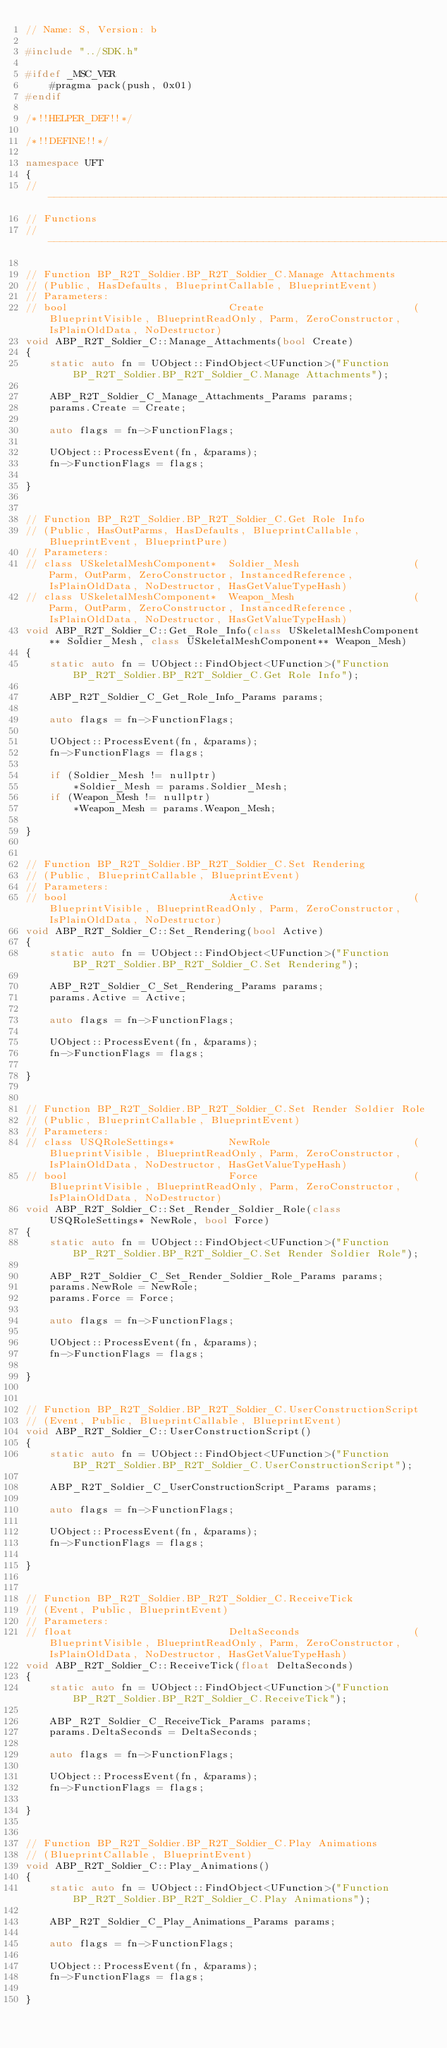Convert code to text. <code><loc_0><loc_0><loc_500><loc_500><_C++_>// Name: S, Version: b

#include "../SDK.h"

#ifdef _MSC_VER
	#pragma pack(push, 0x01)
#endif

/*!!HELPER_DEF!!*/

/*!!DEFINE!!*/

namespace UFT
{
//---------------------------------------------------------------------------
// Functions
//---------------------------------------------------------------------------

// Function BP_R2T_Soldier.BP_R2T_Soldier_C.Manage Attachments
// (Public, HasDefaults, BlueprintCallable, BlueprintEvent)
// Parameters:
// bool                           Create                         (BlueprintVisible, BlueprintReadOnly, Parm, ZeroConstructor, IsPlainOldData, NoDestructor)
void ABP_R2T_Soldier_C::Manage_Attachments(bool Create)
{
	static auto fn = UObject::FindObject<UFunction>("Function BP_R2T_Soldier.BP_R2T_Soldier_C.Manage Attachments");

	ABP_R2T_Soldier_C_Manage_Attachments_Params params;
	params.Create = Create;

	auto flags = fn->FunctionFlags;

	UObject::ProcessEvent(fn, &params);
	fn->FunctionFlags = flags;

}


// Function BP_R2T_Soldier.BP_R2T_Soldier_C.Get Role Info
// (Public, HasOutParms, HasDefaults, BlueprintCallable, BlueprintEvent, BlueprintPure)
// Parameters:
// class USkeletalMeshComponent*  Soldier_Mesh                   (Parm, OutParm, ZeroConstructor, InstancedReference, IsPlainOldData, NoDestructor, HasGetValueTypeHash)
// class USkeletalMeshComponent*  Weapon_Mesh                    (Parm, OutParm, ZeroConstructor, InstancedReference, IsPlainOldData, NoDestructor, HasGetValueTypeHash)
void ABP_R2T_Soldier_C::Get_Role_Info(class USkeletalMeshComponent** Soldier_Mesh, class USkeletalMeshComponent** Weapon_Mesh)
{
	static auto fn = UObject::FindObject<UFunction>("Function BP_R2T_Soldier.BP_R2T_Soldier_C.Get Role Info");

	ABP_R2T_Soldier_C_Get_Role_Info_Params params;

	auto flags = fn->FunctionFlags;

	UObject::ProcessEvent(fn, &params);
	fn->FunctionFlags = flags;

	if (Soldier_Mesh != nullptr)
		*Soldier_Mesh = params.Soldier_Mesh;
	if (Weapon_Mesh != nullptr)
		*Weapon_Mesh = params.Weapon_Mesh;

}


// Function BP_R2T_Soldier.BP_R2T_Soldier_C.Set Rendering
// (Public, BlueprintCallable, BlueprintEvent)
// Parameters:
// bool                           Active                         (BlueprintVisible, BlueprintReadOnly, Parm, ZeroConstructor, IsPlainOldData, NoDestructor)
void ABP_R2T_Soldier_C::Set_Rendering(bool Active)
{
	static auto fn = UObject::FindObject<UFunction>("Function BP_R2T_Soldier.BP_R2T_Soldier_C.Set Rendering");

	ABP_R2T_Soldier_C_Set_Rendering_Params params;
	params.Active = Active;

	auto flags = fn->FunctionFlags;

	UObject::ProcessEvent(fn, &params);
	fn->FunctionFlags = flags;

}


// Function BP_R2T_Soldier.BP_R2T_Soldier_C.Set Render Soldier Role
// (Public, BlueprintCallable, BlueprintEvent)
// Parameters:
// class USQRoleSettings*         NewRole                        (BlueprintVisible, BlueprintReadOnly, Parm, ZeroConstructor, IsPlainOldData, NoDestructor, HasGetValueTypeHash)
// bool                           Force                          (BlueprintVisible, BlueprintReadOnly, Parm, ZeroConstructor, IsPlainOldData, NoDestructor)
void ABP_R2T_Soldier_C::Set_Render_Soldier_Role(class USQRoleSettings* NewRole, bool Force)
{
	static auto fn = UObject::FindObject<UFunction>("Function BP_R2T_Soldier.BP_R2T_Soldier_C.Set Render Soldier Role");

	ABP_R2T_Soldier_C_Set_Render_Soldier_Role_Params params;
	params.NewRole = NewRole;
	params.Force = Force;

	auto flags = fn->FunctionFlags;

	UObject::ProcessEvent(fn, &params);
	fn->FunctionFlags = flags;

}


// Function BP_R2T_Soldier.BP_R2T_Soldier_C.UserConstructionScript
// (Event, Public, BlueprintCallable, BlueprintEvent)
void ABP_R2T_Soldier_C::UserConstructionScript()
{
	static auto fn = UObject::FindObject<UFunction>("Function BP_R2T_Soldier.BP_R2T_Soldier_C.UserConstructionScript");

	ABP_R2T_Soldier_C_UserConstructionScript_Params params;

	auto flags = fn->FunctionFlags;

	UObject::ProcessEvent(fn, &params);
	fn->FunctionFlags = flags;

}


// Function BP_R2T_Soldier.BP_R2T_Soldier_C.ReceiveTick
// (Event, Public, BlueprintEvent)
// Parameters:
// float                          DeltaSeconds                   (BlueprintVisible, BlueprintReadOnly, Parm, ZeroConstructor, IsPlainOldData, NoDestructor, HasGetValueTypeHash)
void ABP_R2T_Soldier_C::ReceiveTick(float DeltaSeconds)
{
	static auto fn = UObject::FindObject<UFunction>("Function BP_R2T_Soldier.BP_R2T_Soldier_C.ReceiveTick");

	ABP_R2T_Soldier_C_ReceiveTick_Params params;
	params.DeltaSeconds = DeltaSeconds;

	auto flags = fn->FunctionFlags;

	UObject::ProcessEvent(fn, &params);
	fn->FunctionFlags = flags;

}


// Function BP_R2T_Soldier.BP_R2T_Soldier_C.Play Animations
// (BlueprintCallable, BlueprintEvent)
void ABP_R2T_Soldier_C::Play_Animations()
{
	static auto fn = UObject::FindObject<UFunction>("Function BP_R2T_Soldier.BP_R2T_Soldier_C.Play Animations");

	ABP_R2T_Soldier_C_Play_Animations_Params params;

	auto flags = fn->FunctionFlags;

	UObject::ProcessEvent(fn, &params);
	fn->FunctionFlags = flags;

}

</code> 